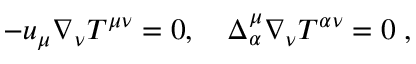Convert formula to latex. <formula><loc_0><loc_0><loc_500><loc_500>- u _ { \mu } \nabla _ { \nu } T ^ { \mu \nu } = 0 , \quad \Delta _ { \alpha } ^ { \mu } \nabla _ { \nu } T ^ { \alpha \nu } = 0 \, ,</formula> 